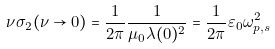Convert formula to latex. <formula><loc_0><loc_0><loc_500><loc_500>\nu \sigma _ { 2 } ( \nu \rightarrow 0 ) = \frac { 1 } { 2 \pi } \frac { 1 } { \mu _ { 0 } \lambda ( 0 ) ^ { 2 } } = \frac { 1 } { 2 \pi } \varepsilon _ { 0 } \omega _ { p , s } ^ { 2 }</formula> 